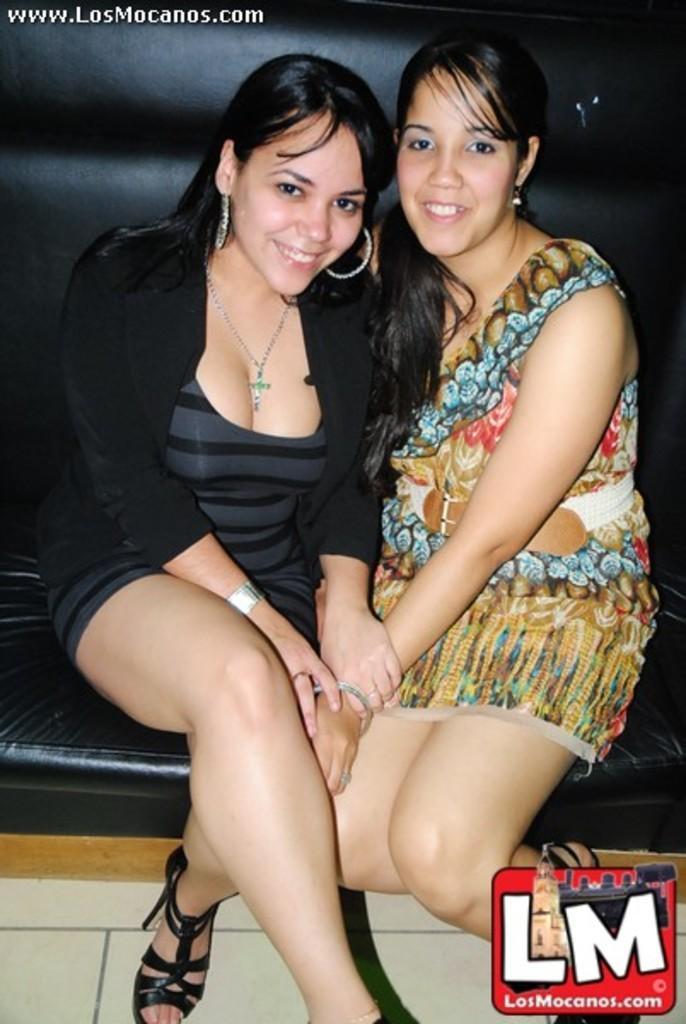Can you describe this image briefly? In the center of the picture we can see two women sitting on a couch, they are smiling. At the bottom it is floor. In the bottom right corner there is a logo. 